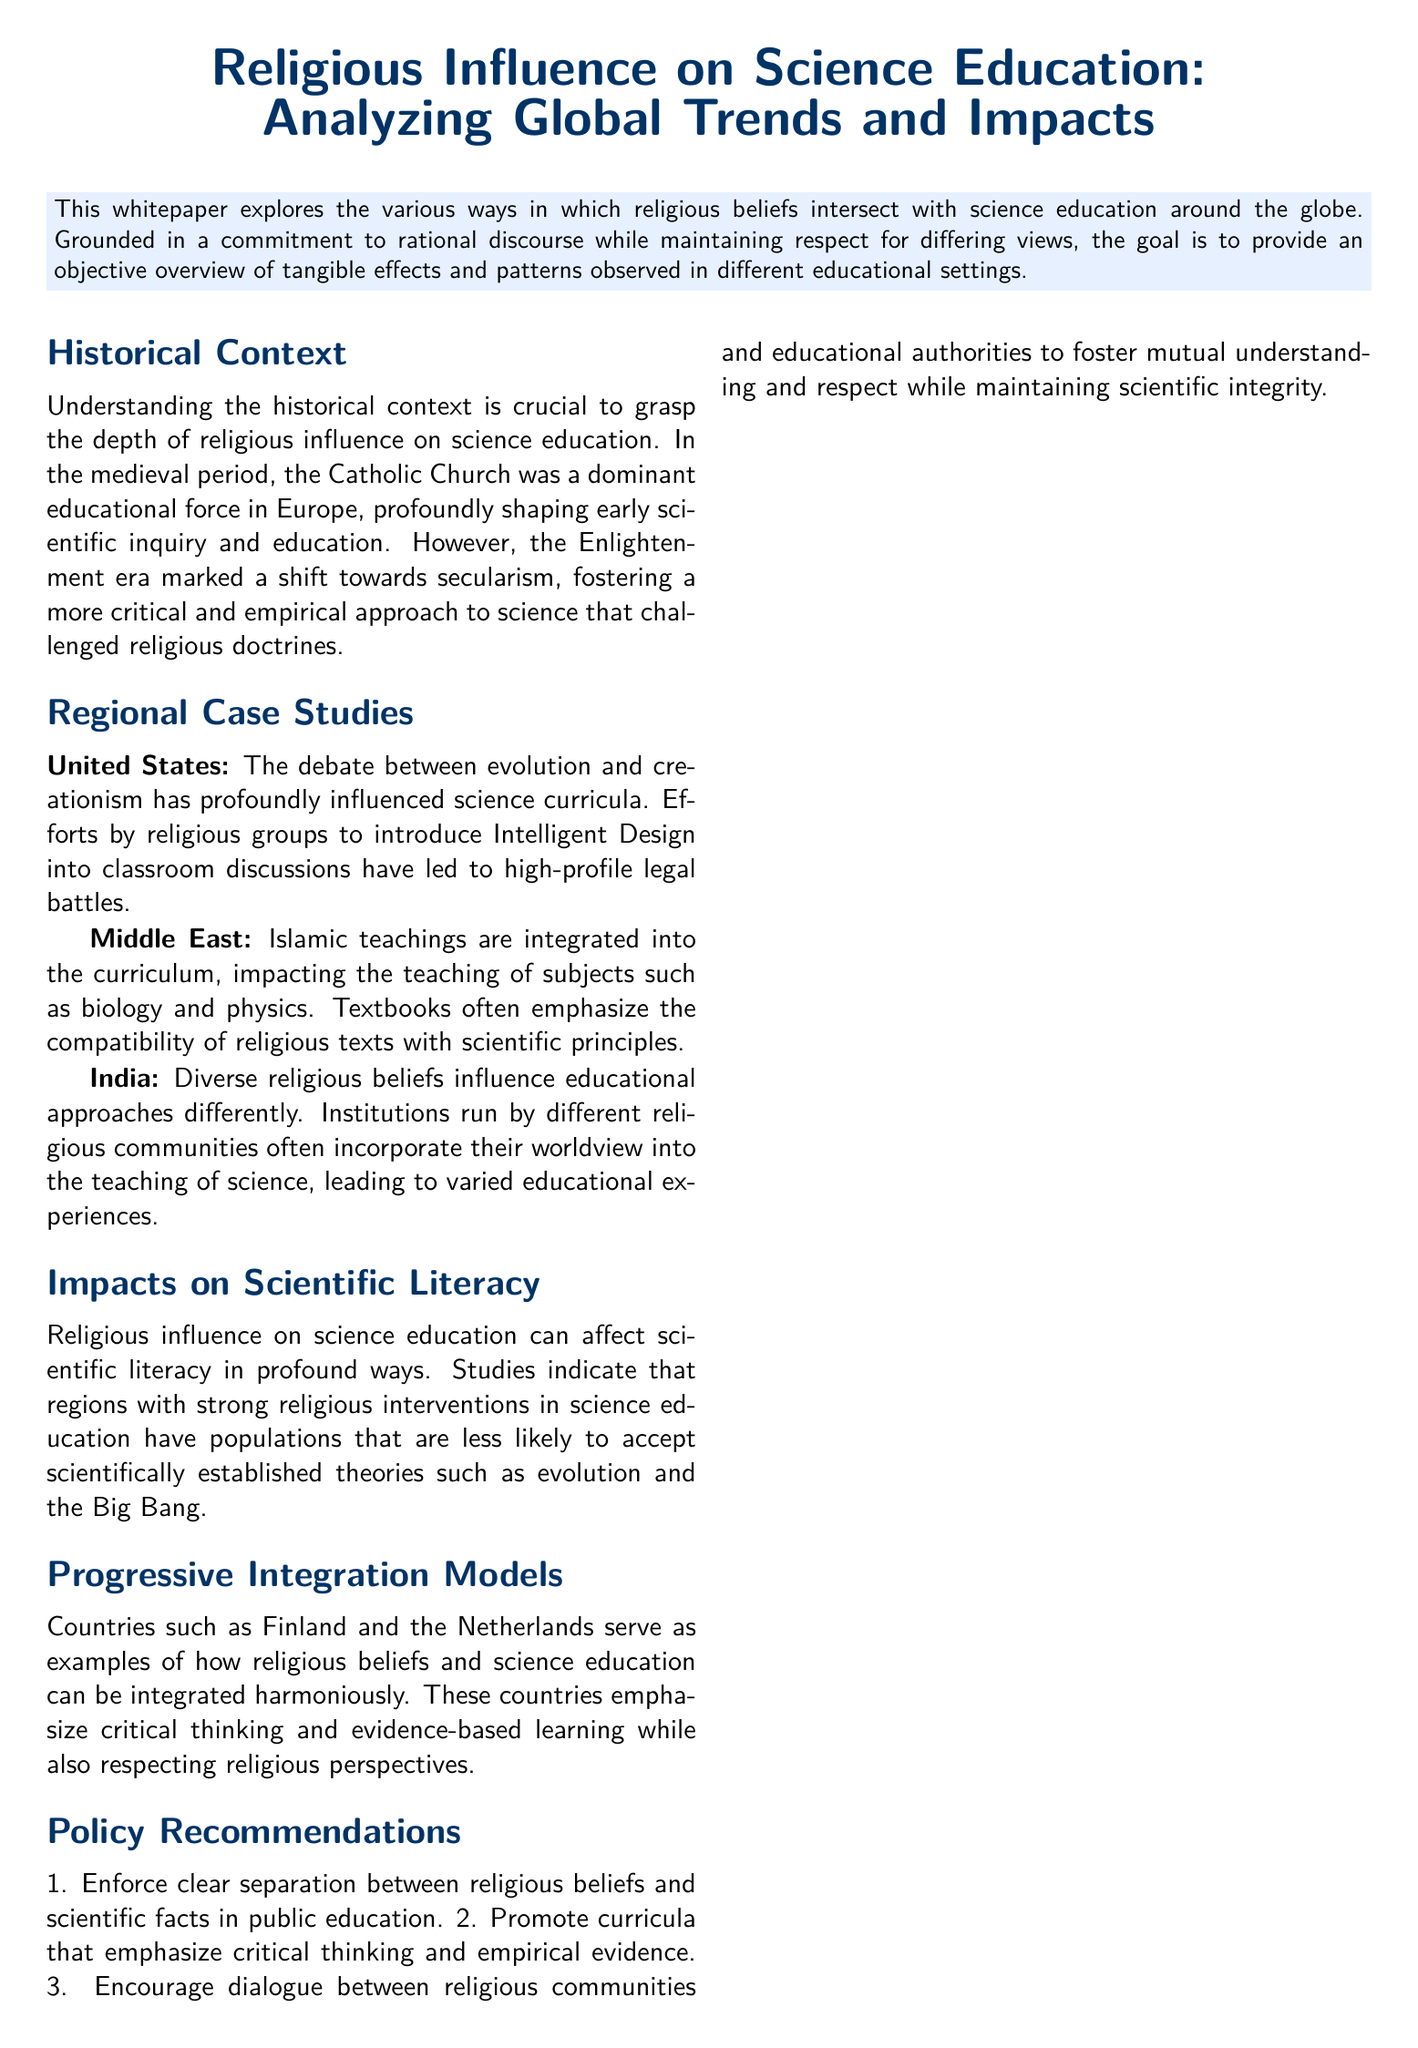What historical period saw the Catholic Church dominate educational influence in Europe? The document mentions the medieval period as the time when the Catholic Church was a dominant educational force.
Answer: medieval period Which two countries are example models of progressive integration of religious beliefs and science education? The document lists Finland and the Netherlands as examples.
Answer: Finland and the Netherlands What impact does strong religious intervention in science education have on scientific literacy? The document states that such interventions lead to populations less likely to accept scientifically established theories.
Answer: less likely to accept scientifically established theories What legal battles are mentioned in relation to the influence of religion on science curricula? The document refers to high-profile legal battles regarding the introduction of Intelligent Design into classroom discussions.
Answer: Intelligent Design What is one of the policy recommendations made in the document? The document recommends enforcing a clear separation between religious beliefs and scientific facts in public education.
Answer: Enforce clear separation between religious beliefs and scientific facts What aspect of education do countries like Finland emphasize while respecting religious perspectives? The document notes that these countries emphasize critical thinking and evidence-based learning.
Answer: critical thinking and evidence-based learning Which region integrates Islamic teachings into the science curriculum? The document specifies the Middle East as the region where Islamic teachings are integrated.
Answer: Middle East What is the primary goal of the whitepaper? The document aims to provide an objective overview of the effects and patterns of religious influence on science education.
Answer: objective overview of the effects and patterns 